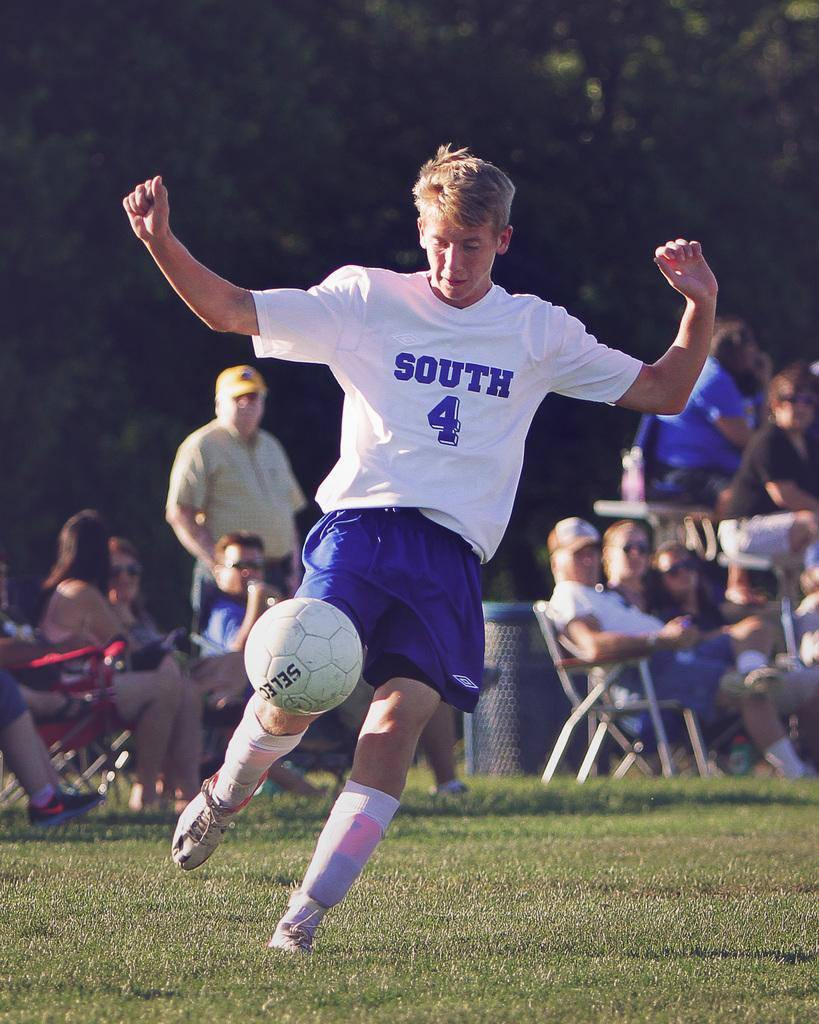What is the main subject of the image? There is a football player in the image. What action is the football player performing? The football player is trying to kick a ball. Are there any spectators in the image? Yes, there are people sitting and watching in the image. Can you tell me how many babies are crawling on the football field in the image? There are no babies present in the image; it features a football player trying to kick a ball with people watching. What type of door can be seen in the image? There is no door present in the image. 